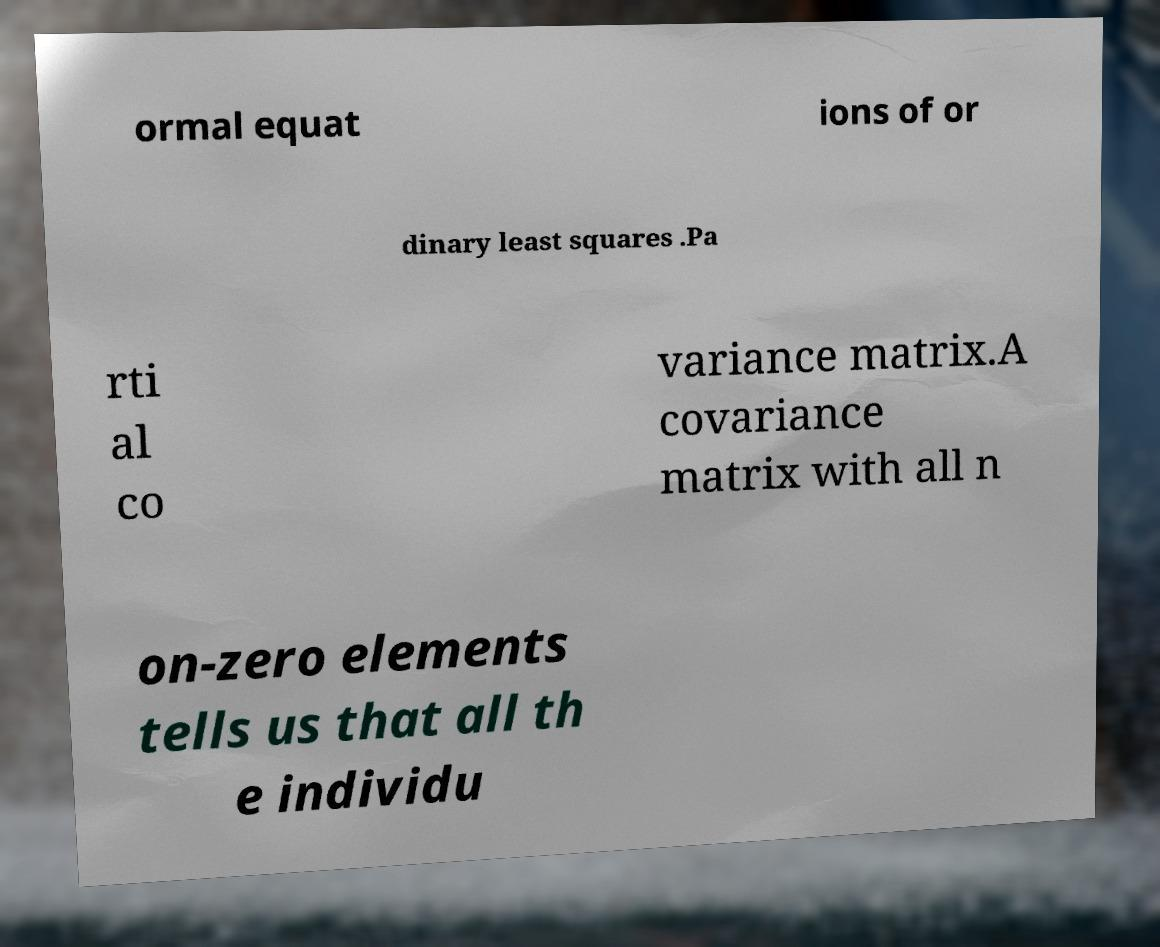Please identify and transcribe the text found in this image. ormal equat ions of or dinary least squares .Pa rti al co variance matrix.A covariance matrix with all n on-zero elements tells us that all th e individu 